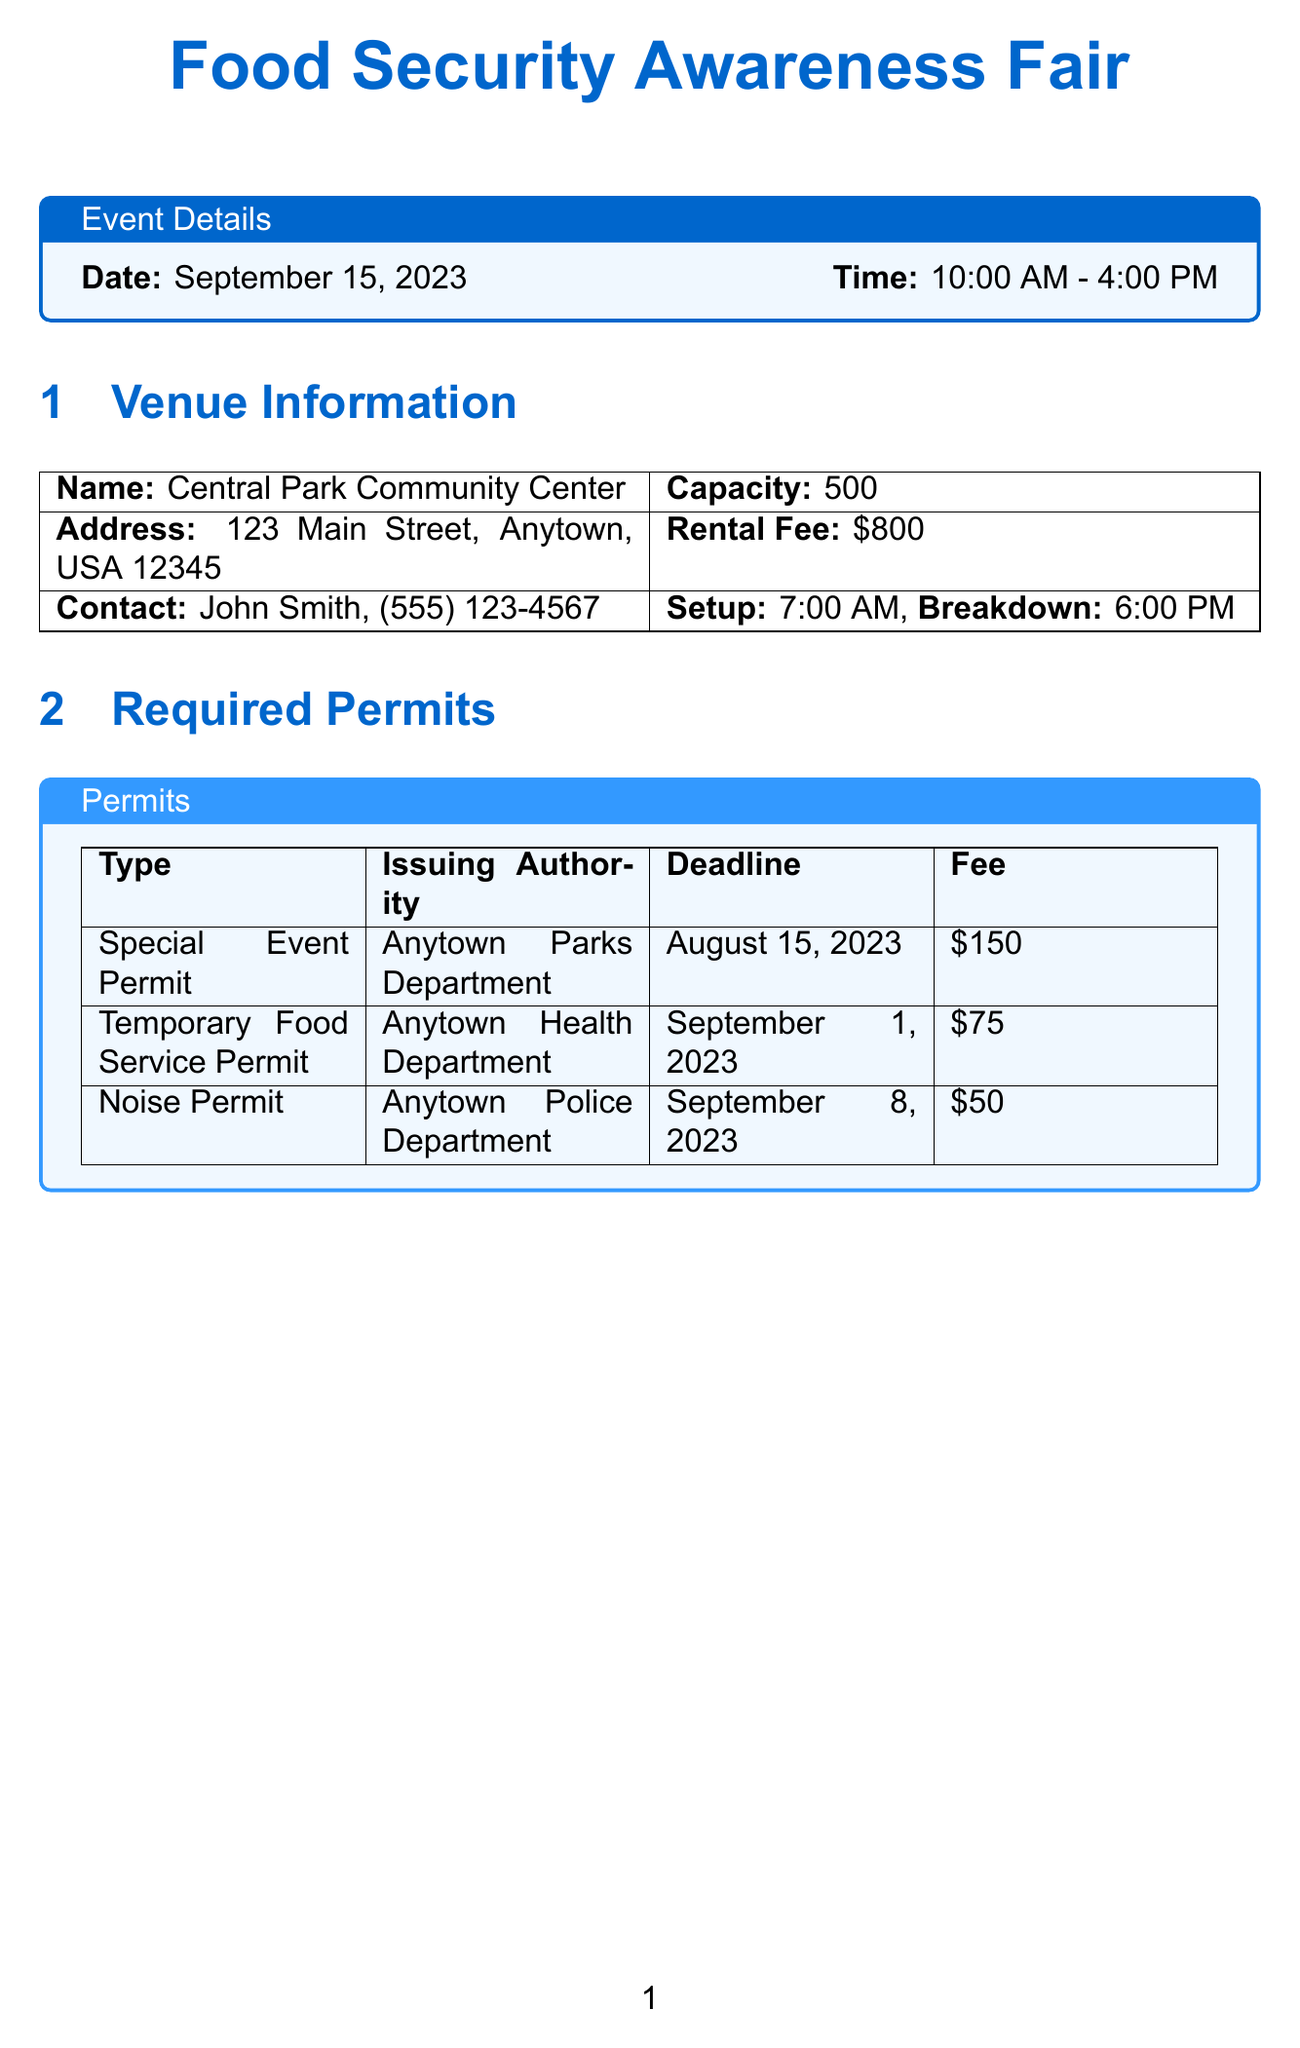what is the name of the event? The name of the event is stated in the document's title at the top.
Answer: Food Security Awareness Fair what is the event date? The event date is specified in the event details section.
Answer: September 15, 2023 what is the total budget for the event? The total budget can be found in the budget overview section of the document.
Answer: $3725 how many volunteers are required for the Children's Activity Area? The number of volunteers assigned to the Children's Activity Area is detailed in the volunteer assignments section.
Answer: 5 who is responsible for the social media campaign? The person responsible for the social media campaign is mentioned in the promotional strategies section.
Answer: Sarah Johnson what type of permit is required for food service? The type of permit related to food service is listed in the required permits section of the document.
Answer: Temporary Food Service Permit how many times will local radio announcements be made before the event? The frequency of local radio announcements is specified in the promotional strategies section.
Answer: 3 times daily what is the contact number for the venue? The contact number for the venue can be found in the venue information section.
Answer: (555) 123-4567 what is the setup time for the venue? The setup time is listed in the venue information section of the document.
Answer: 7:00 AM 